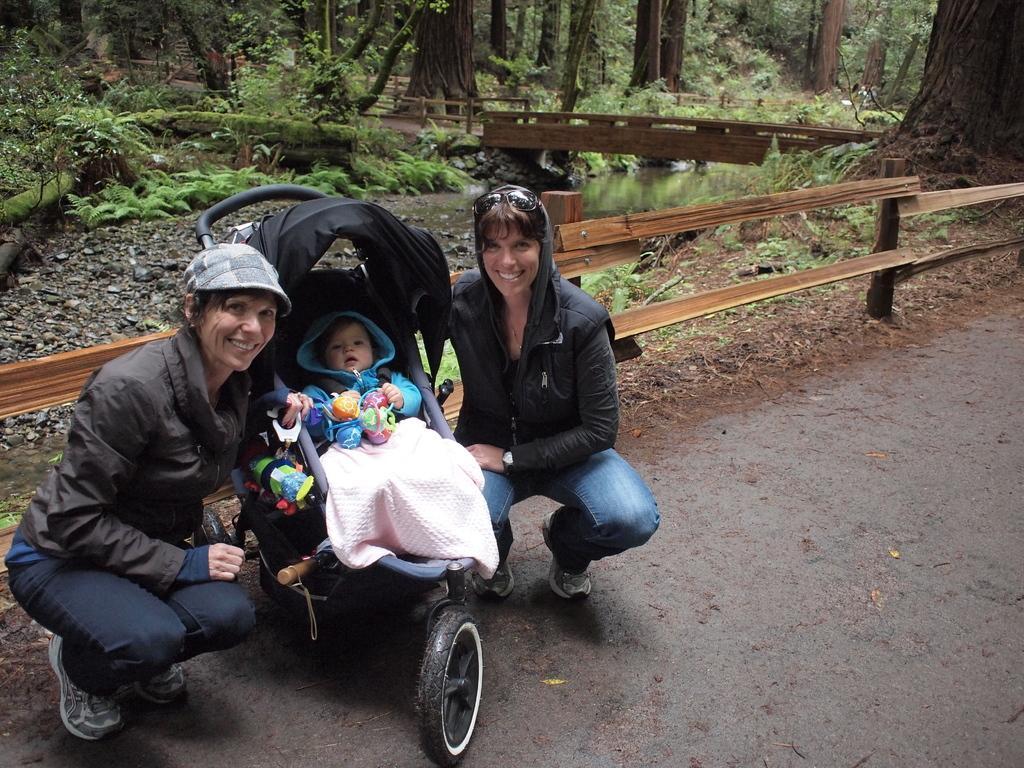How would you summarize this image in a sentence or two? In the middle of the image there is a stroller, in the stroller a baby is sitting. Beside the stroller two women are sitting and smiling. Behind them there is a fencing. Behind the fencing there are some trees and grass. 